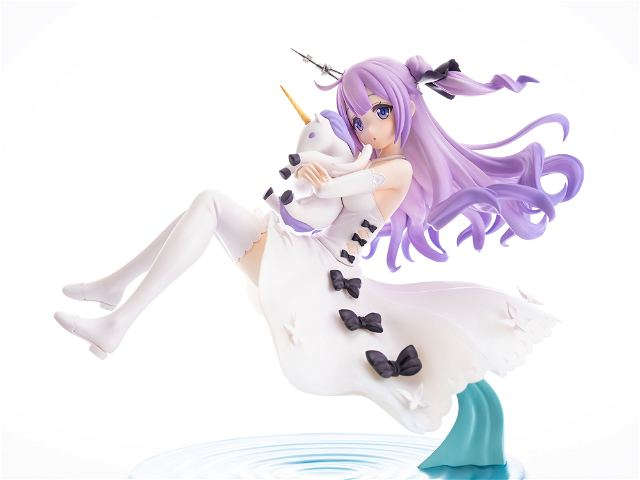Considering the dynamic pose and the design elements of the figure, what might be the implied narrative or theme behind this character's design, and how do the specific details of the figure contribute to that narrative or theme? The figure’s design, with its dynamic pose and ethereal elements, seems to convey a narrative of freedom and enchantment within a fantasy realm. The character is portrayed in mid-leap, holding a unicorn, suggesting themes of purity, innocence, and magical adventures. Her flowing purple hair and the fluid lines of her white dress enhance the feeling of motion, implying she could be floating or flying. Details like the bows, delicate fabric textures, and the subtle hues in her outfit add depth to her character, portraying her as a whimsical, yet thoughtful figure within her magical world. The serene expression and closed eyes could indicate a moment of bliss or deep connection to the magical elements surrounding her. This figure stands as a celebration of fantasy, encouraging viewers to interpret her story as one of joyous liberation in a fantastical setting. 